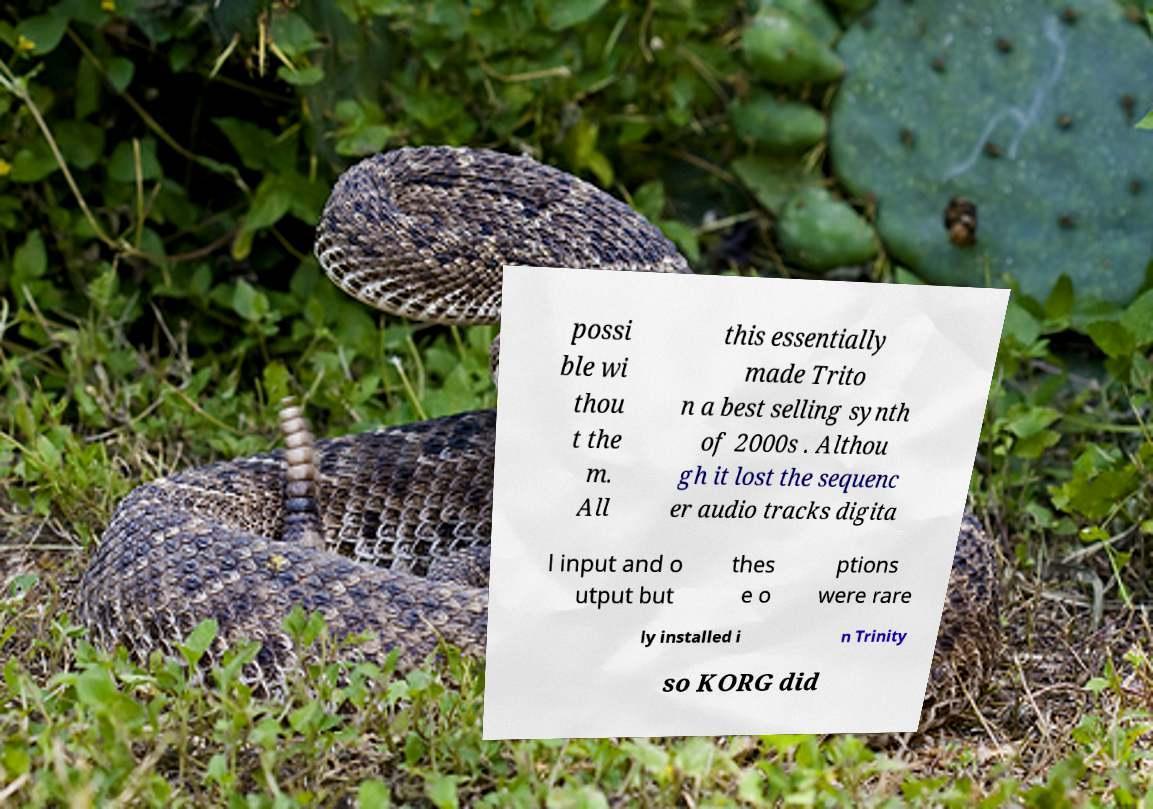Could you assist in decoding the text presented in this image and type it out clearly? possi ble wi thou t the m. All this essentially made Trito n a best selling synth of 2000s . Althou gh it lost the sequenc er audio tracks digita l input and o utput but thes e o ptions were rare ly installed i n Trinity so KORG did 